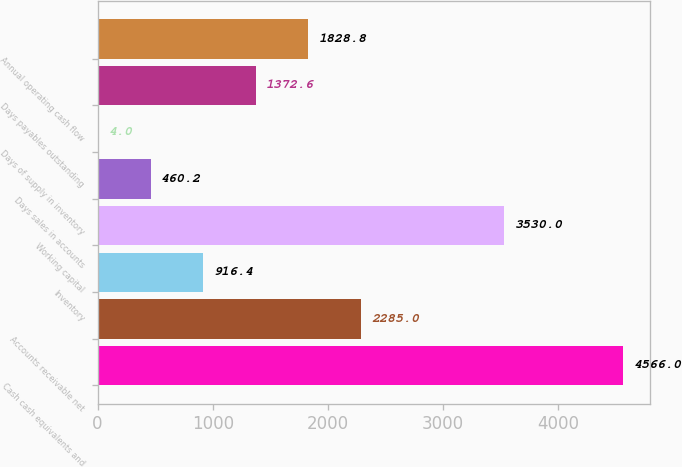<chart> <loc_0><loc_0><loc_500><loc_500><bar_chart><fcel>Cash cash equivalents and<fcel>Accounts receivable net<fcel>Inventory<fcel>Working capital<fcel>Days sales in accounts<fcel>Days of supply in inventory<fcel>Days payables outstanding<fcel>Annual operating cash flow<nl><fcel>4566<fcel>2285<fcel>916.4<fcel>3530<fcel>460.2<fcel>4<fcel>1372.6<fcel>1828.8<nl></chart> 